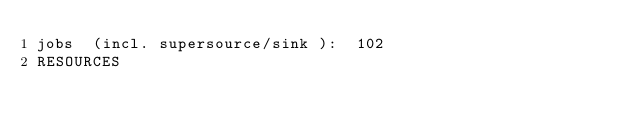Convert code to text. <code><loc_0><loc_0><loc_500><loc_500><_ObjectiveC_>jobs  (incl. supersource/sink ):	102
RESOURCES</code> 